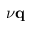Convert formula to latex. <formula><loc_0><loc_0><loc_500><loc_500>\nu q</formula> 